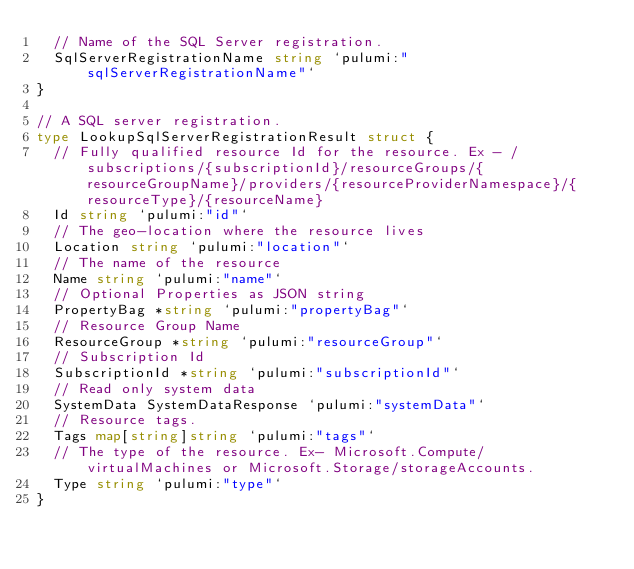<code> <loc_0><loc_0><loc_500><loc_500><_Go_>	// Name of the SQL Server registration.
	SqlServerRegistrationName string `pulumi:"sqlServerRegistrationName"`
}

// A SQL server registration.
type LookupSqlServerRegistrationResult struct {
	// Fully qualified resource Id for the resource. Ex - /subscriptions/{subscriptionId}/resourceGroups/{resourceGroupName}/providers/{resourceProviderNamespace}/{resourceType}/{resourceName}
	Id string `pulumi:"id"`
	// The geo-location where the resource lives
	Location string `pulumi:"location"`
	// The name of the resource
	Name string `pulumi:"name"`
	// Optional Properties as JSON string
	PropertyBag *string `pulumi:"propertyBag"`
	// Resource Group Name
	ResourceGroup *string `pulumi:"resourceGroup"`
	// Subscription Id
	SubscriptionId *string `pulumi:"subscriptionId"`
	// Read only system data
	SystemData SystemDataResponse `pulumi:"systemData"`
	// Resource tags.
	Tags map[string]string `pulumi:"tags"`
	// The type of the resource. Ex- Microsoft.Compute/virtualMachines or Microsoft.Storage/storageAccounts.
	Type string `pulumi:"type"`
}
</code> 